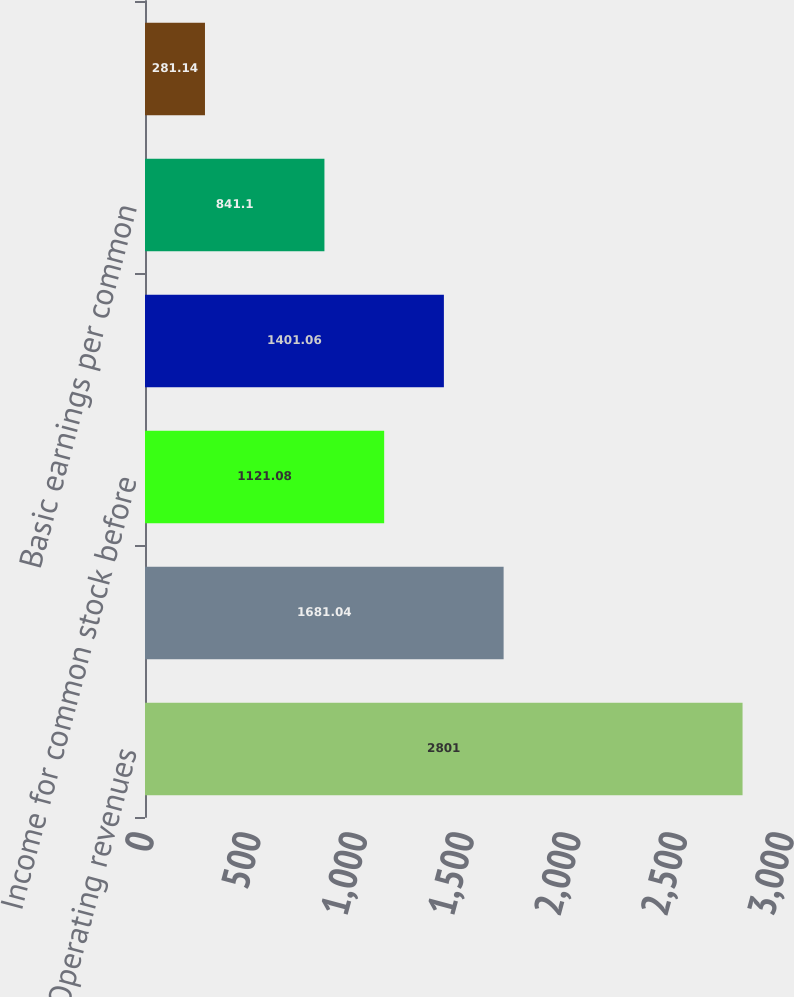Convert chart to OTSL. <chart><loc_0><loc_0><loc_500><loc_500><bar_chart><fcel>Operating revenues<fcel>Operating income<fcel>Income for common stock before<fcel>Net income for common stock<fcel>Basic earnings per common<fcel>Diluted earnings per common<nl><fcel>2801<fcel>1681.04<fcel>1121.08<fcel>1401.06<fcel>841.1<fcel>281.14<nl></chart> 